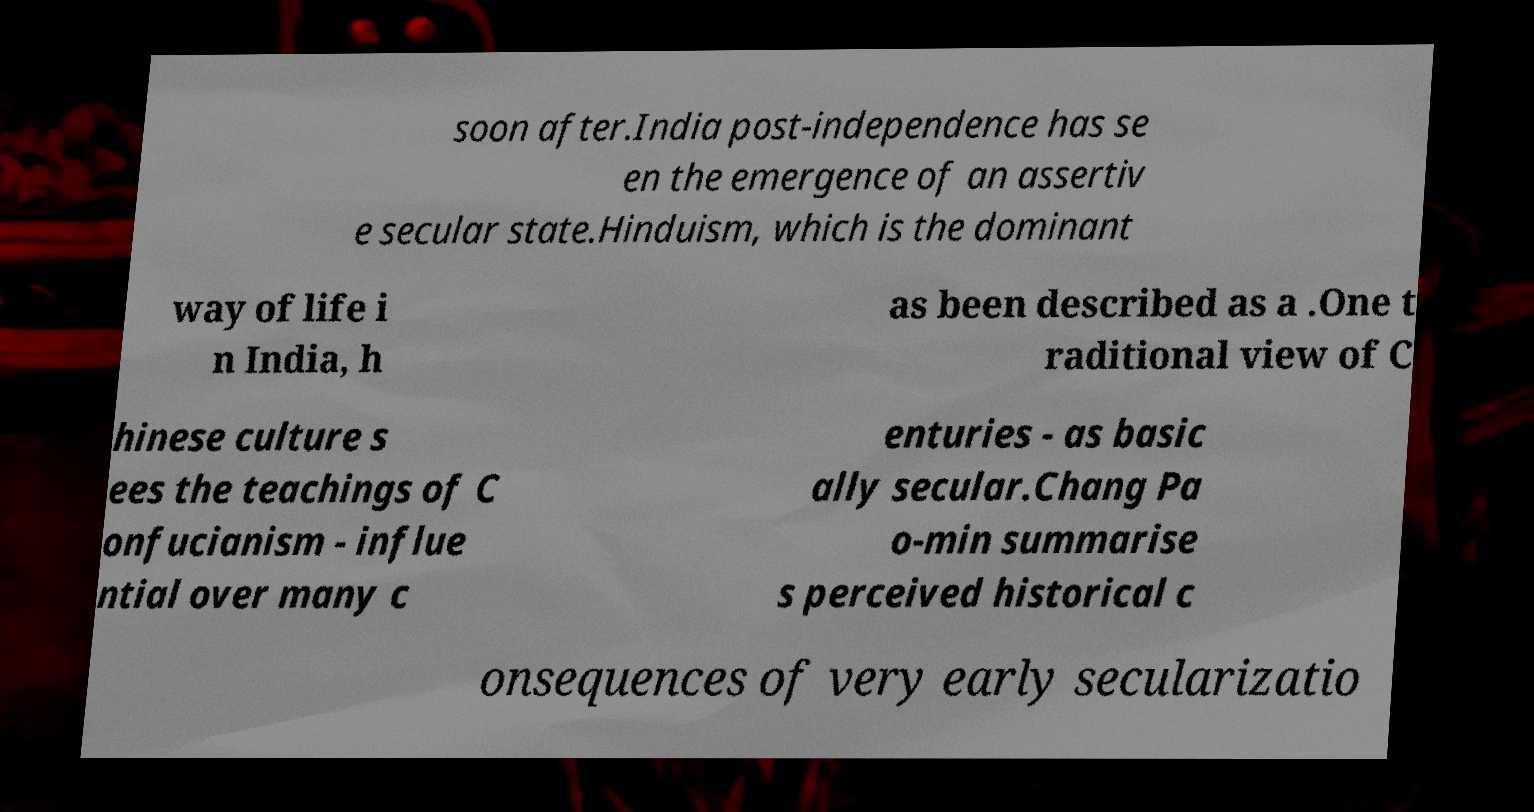Please identify and transcribe the text found in this image. soon after.India post-independence has se en the emergence of an assertiv e secular state.Hinduism, which is the dominant way of life i n India, h as been described as a .One t raditional view of C hinese culture s ees the teachings of C onfucianism - influe ntial over many c enturies - as basic ally secular.Chang Pa o-min summarise s perceived historical c onsequences of very early secularizatio 